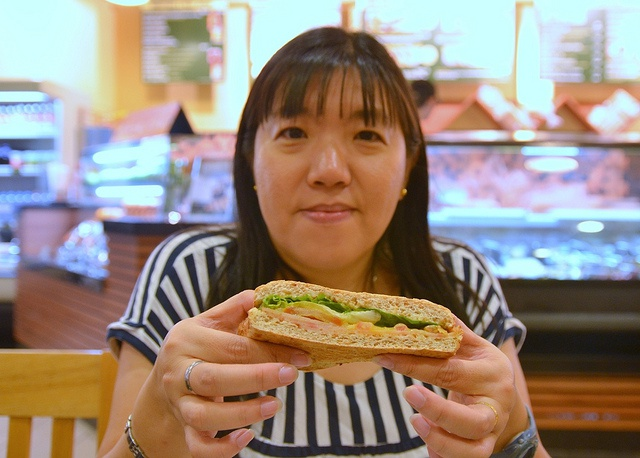Describe the objects in this image and their specific colors. I can see people in lightblue, brown, black, salmon, and maroon tones, sandwich in lightblue, tan, and olive tones, and chair in lightblue, olive, tan, and darkgray tones in this image. 